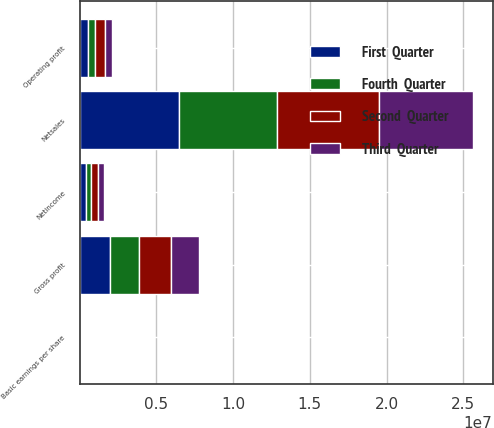Convert chart to OTSL. <chart><loc_0><loc_0><loc_500><loc_500><stacked_bar_chart><ecel><fcel>Netsales<fcel>Gross profit<fcel>Operating profit<fcel>Netincome<fcel>Basic earnings per share<nl><fcel>Third  Quarter<fcel>6.11446e+06<fcel>1.86225e+06<fcel>490184<fcel>364852<fcel>1.36<nl><fcel>First  Quarter<fcel>6.44331e+06<fcel>1.97487e+06<fcel>545476<fcel>407237<fcel>1.53<nl><fcel>Fourth  Quarter<fcel>6.41746e+06<fcel>1.89506e+06<fcel>442143<fcel>334142<fcel>1.26<nl><fcel>Second  Quarter<fcel>6.64981e+06<fcel>2.07169e+06<fcel>638503<fcel>483241<fcel>1.85<nl></chart> 